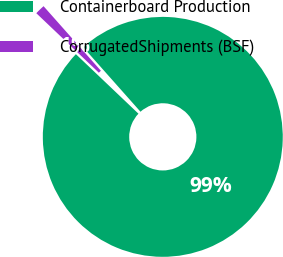Convert chart to OTSL. <chart><loc_0><loc_0><loc_500><loc_500><pie_chart><fcel>Containerboard Production<fcel>CorrugatedShipments (BSF)<nl><fcel>98.66%<fcel>1.34%<nl></chart> 